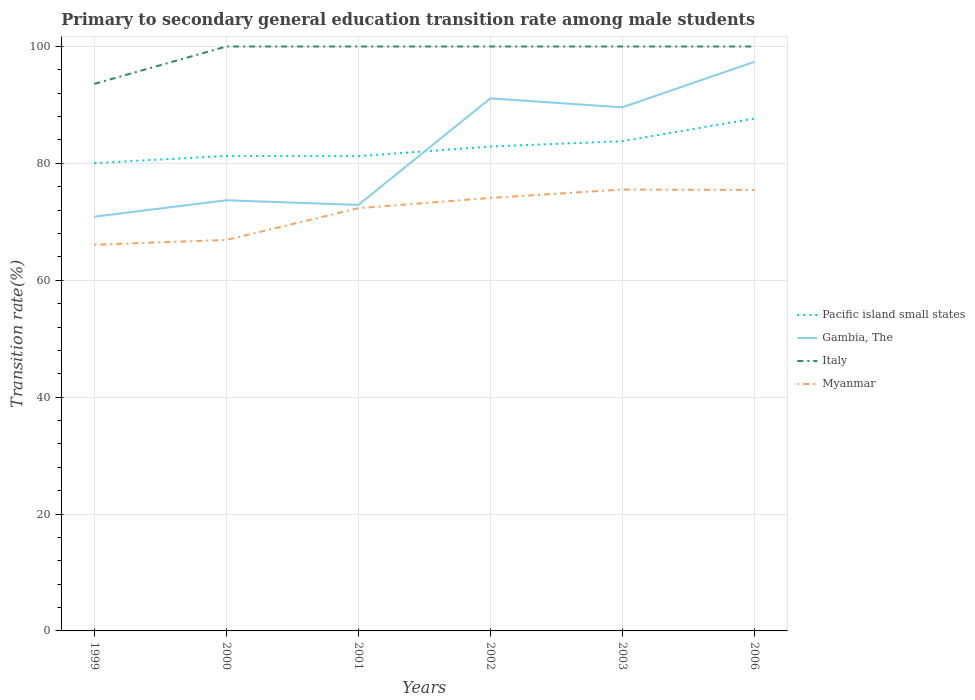Across all years, what is the maximum transition rate in Gambia, The?
Provide a succinct answer. 70.88. In which year was the transition rate in Pacific island small states maximum?
Offer a very short reply. 1999. What is the total transition rate in Italy in the graph?
Offer a very short reply. 0. What is the difference between the highest and the second highest transition rate in Italy?
Make the answer very short. 6.4. What is the difference between the highest and the lowest transition rate in Gambia, The?
Offer a very short reply. 3. Is the transition rate in Myanmar strictly greater than the transition rate in Italy over the years?
Make the answer very short. Yes. How many lines are there?
Provide a succinct answer. 4. Are the values on the major ticks of Y-axis written in scientific E-notation?
Offer a terse response. No. Does the graph contain grids?
Offer a terse response. Yes. Where does the legend appear in the graph?
Your answer should be very brief. Center right. How are the legend labels stacked?
Give a very brief answer. Vertical. What is the title of the graph?
Make the answer very short. Primary to secondary general education transition rate among male students. Does "Zambia" appear as one of the legend labels in the graph?
Your answer should be very brief. No. What is the label or title of the Y-axis?
Offer a terse response. Transition rate(%). What is the Transition rate(%) in Pacific island small states in 1999?
Your answer should be compact. 80.04. What is the Transition rate(%) in Gambia, The in 1999?
Your answer should be compact. 70.88. What is the Transition rate(%) in Italy in 1999?
Provide a succinct answer. 93.6. What is the Transition rate(%) of Myanmar in 1999?
Keep it short and to the point. 66.07. What is the Transition rate(%) in Pacific island small states in 2000?
Offer a very short reply. 81.27. What is the Transition rate(%) in Gambia, The in 2000?
Ensure brevity in your answer.  73.69. What is the Transition rate(%) in Myanmar in 2000?
Make the answer very short. 66.9. What is the Transition rate(%) in Pacific island small states in 2001?
Offer a terse response. 81.23. What is the Transition rate(%) in Gambia, The in 2001?
Give a very brief answer. 72.89. What is the Transition rate(%) in Italy in 2001?
Provide a short and direct response. 100. What is the Transition rate(%) of Myanmar in 2001?
Ensure brevity in your answer.  72.33. What is the Transition rate(%) in Pacific island small states in 2002?
Provide a short and direct response. 82.88. What is the Transition rate(%) in Gambia, The in 2002?
Offer a terse response. 91.12. What is the Transition rate(%) of Myanmar in 2002?
Offer a terse response. 74.09. What is the Transition rate(%) of Pacific island small states in 2003?
Offer a terse response. 83.8. What is the Transition rate(%) in Gambia, The in 2003?
Offer a terse response. 89.59. What is the Transition rate(%) of Myanmar in 2003?
Provide a short and direct response. 75.52. What is the Transition rate(%) in Pacific island small states in 2006?
Your answer should be compact. 87.67. What is the Transition rate(%) of Gambia, The in 2006?
Your answer should be compact. 97.38. What is the Transition rate(%) in Myanmar in 2006?
Your answer should be very brief. 75.45. Across all years, what is the maximum Transition rate(%) of Pacific island small states?
Ensure brevity in your answer.  87.67. Across all years, what is the maximum Transition rate(%) in Gambia, The?
Ensure brevity in your answer.  97.38. Across all years, what is the maximum Transition rate(%) in Italy?
Offer a very short reply. 100. Across all years, what is the maximum Transition rate(%) of Myanmar?
Your answer should be very brief. 75.52. Across all years, what is the minimum Transition rate(%) in Pacific island small states?
Offer a very short reply. 80.04. Across all years, what is the minimum Transition rate(%) in Gambia, The?
Your answer should be very brief. 70.88. Across all years, what is the minimum Transition rate(%) in Italy?
Your response must be concise. 93.6. Across all years, what is the minimum Transition rate(%) in Myanmar?
Your answer should be compact. 66.07. What is the total Transition rate(%) in Pacific island small states in the graph?
Offer a very short reply. 496.89. What is the total Transition rate(%) in Gambia, The in the graph?
Provide a short and direct response. 495.54. What is the total Transition rate(%) in Italy in the graph?
Your response must be concise. 593.6. What is the total Transition rate(%) in Myanmar in the graph?
Offer a very short reply. 430.37. What is the difference between the Transition rate(%) of Pacific island small states in 1999 and that in 2000?
Keep it short and to the point. -1.24. What is the difference between the Transition rate(%) in Gambia, The in 1999 and that in 2000?
Ensure brevity in your answer.  -2.81. What is the difference between the Transition rate(%) of Italy in 1999 and that in 2000?
Your answer should be very brief. -6.4. What is the difference between the Transition rate(%) in Myanmar in 1999 and that in 2000?
Give a very brief answer. -0.83. What is the difference between the Transition rate(%) of Pacific island small states in 1999 and that in 2001?
Offer a very short reply. -1.2. What is the difference between the Transition rate(%) of Gambia, The in 1999 and that in 2001?
Ensure brevity in your answer.  -2.01. What is the difference between the Transition rate(%) in Italy in 1999 and that in 2001?
Make the answer very short. -6.4. What is the difference between the Transition rate(%) of Myanmar in 1999 and that in 2001?
Your answer should be very brief. -6.25. What is the difference between the Transition rate(%) in Pacific island small states in 1999 and that in 2002?
Your answer should be very brief. -2.84. What is the difference between the Transition rate(%) in Gambia, The in 1999 and that in 2002?
Offer a terse response. -20.24. What is the difference between the Transition rate(%) of Italy in 1999 and that in 2002?
Your response must be concise. -6.4. What is the difference between the Transition rate(%) in Myanmar in 1999 and that in 2002?
Keep it short and to the point. -8.02. What is the difference between the Transition rate(%) of Pacific island small states in 1999 and that in 2003?
Keep it short and to the point. -3.76. What is the difference between the Transition rate(%) of Gambia, The in 1999 and that in 2003?
Offer a very short reply. -18.71. What is the difference between the Transition rate(%) of Italy in 1999 and that in 2003?
Give a very brief answer. -6.4. What is the difference between the Transition rate(%) of Myanmar in 1999 and that in 2003?
Your answer should be compact. -9.45. What is the difference between the Transition rate(%) of Pacific island small states in 1999 and that in 2006?
Provide a succinct answer. -7.63. What is the difference between the Transition rate(%) of Gambia, The in 1999 and that in 2006?
Your response must be concise. -26.5. What is the difference between the Transition rate(%) in Italy in 1999 and that in 2006?
Give a very brief answer. -6.4. What is the difference between the Transition rate(%) in Myanmar in 1999 and that in 2006?
Your answer should be very brief. -9.38. What is the difference between the Transition rate(%) in Pacific island small states in 2000 and that in 2001?
Ensure brevity in your answer.  0.04. What is the difference between the Transition rate(%) of Gambia, The in 2000 and that in 2001?
Offer a very short reply. 0.8. What is the difference between the Transition rate(%) of Myanmar in 2000 and that in 2001?
Your response must be concise. -5.43. What is the difference between the Transition rate(%) of Pacific island small states in 2000 and that in 2002?
Ensure brevity in your answer.  -1.61. What is the difference between the Transition rate(%) of Gambia, The in 2000 and that in 2002?
Your answer should be compact. -17.43. What is the difference between the Transition rate(%) of Myanmar in 2000 and that in 2002?
Your answer should be compact. -7.19. What is the difference between the Transition rate(%) in Pacific island small states in 2000 and that in 2003?
Provide a short and direct response. -2.52. What is the difference between the Transition rate(%) in Gambia, The in 2000 and that in 2003?
Provide a short and direct response. -15.9. What is the difference between the Transition rate(%) in Myanmar in 2000 and that in 2003?
Offer a terse response. -8.62. What is the difference between the Transition rate(%) of Pacific island small states in 2000 and that in 2006?
Keep it short and to the point. -6.4. What is the difference between the Transition rate(%) in Gambia, The in 2000 and that in 2006?
Your answer should be very brief. -23.69. What is the difference between the Transition rate(%) in Italy in 2000 and that in 2006?
Ensure brevity in your answer.  0. What is the difference between the Transition rate(%) in Myanmar in 2000 and that in 2006?
Your answer should be compact. -8.55. What is the difference between the Transition rate(%) in Pacific island small states in 2001 and that in 2002?
Your response must be concise. -1.65. What is the difference between the Transition rate(%) in Gambia, The in 2001 and that in 2002?
Offer a very short reply. -18.23. What is the difference between the Transition rate(%) of Myanmar in 2001 and that in 2002?
Give a very brief answer. -1.76. What is the difference between the Transition rate(%) in Pacific island small states in 2001 and that in 2003?
Provide a short and direct response. -2.56. What is the difference between the Transition rate(%) of Gambia, The in 2001 and that in 2003?
Offer a terse response. -16.7. What is the difference between the Transition rate(%) of Myanmar in 2001 and that in 2003?
Ensure brevity in your answer.  -3.19. What is the difference between the Transition rate(%) of Pacific island small states in 2001 and that in 2006?
Your answer should be very brief. -6.44. What is the difference between the Transition rate(%) in Gambia, The in 2001 and that in 2006?
Ensure brevity in your answer.  -24.49. What is the difference between the Transition rate(%) of Myanmar in 2001 and that in 2006?
Provide a succinct answer. -3.12. What is the difference between the Transition rate(%) of Pacific island small states in 2002 and that in 2003?
Ensure brevity in your answer.  -0.92. What is the difference between the Transition rate(%) in Gambia, The in 2002 and that in 2003?
Your response must be concise. 1.53. What is the difference between the Transition rate(%) of Italy in 2002 and that in 2003?
Offer a very short reply. 0. What is the difference between the Transition rate(%) in Myanmar in 2002 and that in 2003?
Your answer should be very brief. -1.43. What is the difference between the Transition rate(%) in Pacific island small states in 2002 and that in 2006?
Ensure brevity in your answer.  -4.79. What is the difference between the Transition rate(%) of Gambia, The in 2002 and that in 2006?
Your answer should be very brief. -6.26. What is the difference between the Transition rate(%) in Italy in 2002 and that in 2006?
Your response must be concise. 0. What is the difference between the Transition rate(%) in Myanmar in 2002 and that in 2006?
Provide a short and direct response. -1.36. What is the difference between the Transition rate(%) in Pacific island small states in 2003 and that in 2006?
Ensure brevity in your answer.  -3.87. What is the difference between the Transition rate(%) in Gambia, The in 2003 and that in 2006?
Make the answer very short. -7.79. What is the difference between the Transition rate(%) in Myanmar in 2003 and that in 2006?
Ensure brevity in your answer.  0.07. What is the difference between the Transition rate(%) of Pacific island small states in 1999 and the Transition rate(%) of Gambia, The in 2000?
Keep it short and to the point. 6.35. What is the difference between the Transition rate(%) of Pacific island small states in 1999 and the Transition rate(%) of Italy in 2000?
Your answer should be very brief. -19.96. What is the difference between the Transition rate(%) of Pacific island small states in 1999 and the Transition rate(%) of Myanmar in 2000?
Give a very brief answer. 13.14. What is the difference between the Transition rate(%) in Gambia, The in 1999 and the Transition rate(%) in Italy in 2000?
Offer a terse response. -29.12. What is the difference between the Transition rate(%) in Gambia, The in 1999 and the Transition rate(%) in Myanmar in 2000?
Your answer should be very brief. 3.98. What is the difference between the Transition rate(%) in Italy in 1999 and the Transition rate(%) in Myanmar in 2000?
Offer a very short reply. 26.7. What is the difference between the Transition rate(%) of Pacific island small states in 1999 and the Transition rate(%) of Gambia, The in 2001?
Your response must be concise. 7.15. What is the difference between the Transition rate(%) in Pacific island small states in 1999 and the Transition rate(%) in Italy in 2001?
Ensure brevity in your answer.  -19.96. What is the difference between the Transition rate(%) of Pacific island small states in 1999 and the Transition rate(%) of Myanmar in 2001?
Your answer should be very brief. 7.71. What is the difference between the Transition rate(%) of Gambia, The in 1999 and the Transition rate(%) of Italy in 2001?
Offer a terse response. -29.12. What is the difference between the Transition rate(%) of Gambia, The in 1999 and the Transition rate(%) of Myanmar in 2001?
Offer a terse response. -1.45. What is the difference between the Transition rate(%) of Italy in 1999 and the Transition rate(%) of Myanmar in 2001?
Give a very brief answer. 21.28. What is the difference between the Transition rate(%) in Pacific island small states in 1999 and the Transition rate(%) in Gambia, The in 2002?
Make the answer very short. -11.08. What is the difference between the Transition rate(%) in Pacific island small states in 1999 and the Transition rate(%) in Italy in 2002?
Make the answer very short. -19.96. What is the difference between the Transition rate(%) in Pacific island small states in 1999 and the Transition rate(%) in Myanmar in 2002?
Your answer should be very brief. 5.95. What is the difference between the Transition rate(%) of Gambia, The in 1999 and the Transition rate(%) of Italy in 2002?
Keep it short and to the point. -29.12. What is the difference between the Transition rate(%) in Gambia, The in 1999 and the Transition rate(%) in Myanmar in 2002?
Provide a succinct answer. -3.21. What is the difference between the Transition rate(%) in Italy in 1999 and the Transition rate(%) in Myanmar in 2002?
Your response must be concise. 19.51. What is the difference between the Transition rate(%) in Pacific island small states in 1999 and the Transition rate(%) in Gambia, The in 2003?
Your response must be concise. -9.55. What is the difference between the Transition rate(%) in Pacific island small states in 1999 and the Transition rate(%) in Italy in 2003?
Your answer should be compact. -19.96. What is the difference between the Transition rate(%) of Pacific island small states in 1999 and the Transition rate(%) of Myanmar in 2003?
Your response must be concise. 4.51. What is the difference between the Transition rate(%) in Gambia, The in 1999 and the Transition rate(%) in Italy in 2003?
Keep it short and to the point. -29.12. What is the difference between the Transition rate(%) in Gambia, The in 1999 and the Transition rate(%) in Myanmar in 2003?
Ensure brevity in your answer.  -4.64. What is the difference between the Transition rate(%) in Italy in 1999 and the Transition rate(%) in Myanmar in 2003?
Offer a terse response. 18.08. What is the difference between the Transition rate(%) in Pacific island small states in 1999 and the Transition rate(%) in Gambia, The in 2006?
Your answer should be very brief. -17.34. What is the difference between the Transition rate(%) of Pacific island small states in 1999 and the Transition rate(%) of Italy in 2006?
Ensure brevity in your answer.  -19.96. What is the difference between the Transition rate(%) of Pacific island small states in 1999 and the Transition rate(%) of Myanmar in 2006?
Your answer should be compact. 4.59. What is the difference between the Transition rate(%) of Gambia, The in 1999 and the Transition rate(%) of Italy in 2006?
Give a very brief answer. -29.12. What is the difference between the Transition rate(%) of Gambia, The in 1999 and the Transition rate(%) of Myanmar in 2006?
Give a very brief answer. -4.57. What is the difference between the Transition rate(%) of Italy in 1999 and the Transition rate(%) of Myanmar in 2006?
Keep it short and to the point. 18.15. What is the difference between the Transition rate(%) in Pacific island small states in 2000 and the Transition rate(%) in Gambia, The in 2001?
Your response must be concise. 8.38. What is the difference between the Transition rate(%) of Pacific island small states in 2000 and the Transition rate(%) of Italy in 2001?
Ensure brevity in your answer.  -18.73. What is the difference between the Transition rate(%) of Pacific island small states in 2000 and the Transition rate(%) of Myanmar in 2001?
Your response must be concise. 8.95. What is the difference between the Transition rate(%) in Gambia, The in 2000 and the Transition rate(%) in Italy in 2001?
Offer a terse response. -26.31. What is the difference between the Transition rate(%) of Gambia, The in 2000 and the Transition rate(%) of Myanmar in 2001?
Provide a succinct answer. 1.36. What is the difference between the Transition rate(%) of Italy in 2000 and the Transition rate(%) of Myanmar in 2001?
Your answer should be very brief. 27.67. What is the difference between the Transition rate(%) of Pacific island small states in 2000 and the Transition rate(%) of Gambia, The in 2002?
Provide a succinct answer. -9.85. What is the difference between the Transition rate(%) in Pacific island small states in 2000 and the Transition rate(%) in Italy in 2002?
Keep it short and to the point. -18.73. What is the difference between the Transition rate(%) in Pacific island small states in 2000 and the Transition rate(%) in Myanmar in 2002?
Provide a succinct answer. 7.18. What is the difference between the Transition rate(%) of Gambia, The in 2000 and the Transition rate(%) of Italy in 2002?
Your response must be concise. -26.31. What is the difference between the Transition rate(%) in Gambia, The in 2000 and the Transition rate(%) in Myanmar in 2002?
Make the answer very short. -0.4. What is the difference between the Transition rate(%) of Italy in 2000 and the Transition rate(%) of Myanmar in 2002?
Provide a succinct answer. 25.91. What is the difference between the Transition rate(%) in Pacific island small states in 2000 and the Transition rate(%) in Gambia, The in 2003?
Ensure brevity in your answer.  -8.32. What is the difference between the Transition rate(%) in Pacific island small states in 2000 and the Transition rate(%) in Italy in 2003?
Your response must be concise. -18.73. What is the difference between the Transition rate(%) of Pacific island small states in 2000 and the Transition rate(%) of Myanmar in 2003?
Keep it short and to the point. 5.75. What is the difference between the Transition rate(%) of Gambia, The in 2000 and the Transition rate(%) of Italy in 2003?
Your answer should be compact. -26.31. What is the difference between the Transition rate(%) in Gambia, The in 2000 and the Transition rate(%) in Myanmar in 2003?
Your answer should be very brief. -1.84. What is the difference between the Transition rate(%) in Italy in 2000 and the Transition rate(%) in Myanmar in 2003?
Provide a succinct answer. 24.48. What is the difference between the Transition rate(%) of Pacific island small states in 2000 and the Transition rate(%) of Gambia, The in 2006?
Your answer should be compact. -16.1. What is the difference between the Transition rate(%) of Pacific island small states in 2000 and the Transition rate(%) of Italy in 2006?
Offer a terse response. -18.73. What is the difference between the Transition rate(%) in Pacific island small states in 2000 and the Transition rate(%) in Myanmar in 2006?
Offer a terse response. 5.82. What is the difference between the Transition rate(%) of Gambia, The in 2000 and the Transition rate(%) of Italy in 2006?
Your answer should be compact. -26.31. What is the difference between the Transition rate(%) of Gambia, The in 2000 and the Transition rate(%) of Myanmar in 2006?
Provide a short and direct response. -1.76. What is the difference between the Transition rate(%) of Italy in 2000 and the Transition rate(%) of Myanmar in 2006?
Offer a terse response. 24.55. What is the difference between the Transition rate(%) of Pacific island small states in 2001 and the Transition rate(%) of Gambia, The in 2002?
Make the answer very short. -9.89. What is the difference between the Transition rate(%) of Pacific island small states in 2001 and the Transition rate(%) of Italy in 2002?
Make the answer very short. -18.77. What is the difference between the Transition rate(%) in Pacific island small states in 2001 and the Transition rate(%) in Myanmar in 2002?
Keep it short and to the point. 7.14. What is the difference between the Transition rate(%) in Gambia, The in 2001 and the Transition rate(%) in Italy in 2002?
Make the answer very short. -27.11. What is the difference between the Transition rate(%) in Gambia, The in 2001 and the Transition rate(%) in Myanmar in 2002?
Offer a very short reply. -1.2. What is the difference between the Transition rate(%) in Italy in 2001 and the Transition rate(%) in Myanmar in 2002?
Your answer should be very brief. 25.91. What is the difference between the Transition rate(%) of Pacific island small states in 2001 and the Transition rate(%) of Gambia, The in 2003?
Your response must be concise. -8.36. What is the difference between the Transition rate(%) of Pacific island small states in 2001 and the Transition rate(%) of Italy in 2003?
Ensure brevity in your answer.  -18.77. What is the difference between the Transition rate(%) in Pacific island small states in 2001 and the Transition rate(%) in Myanmar in 2003?
Offer a terse response. 5.71. What is the difference between the Transition rate(%) in Gambia, The in 2001 and the Transition rate(%) in Italy in 2003?
Ensure brevity in your answer.  -27.11. What is the difference between the Transition rate(%) in Gambia, The in 2001 and the Transition rate(%) in Myanmar in 2003?
Your response must be concise. -2.63. What is the difference between the Transition rate(%) of Italy in 2001 and the Transition rate(%) of Myanmar in 2003?
Give a very brief answer. 24.48. What is the difference between the Transition rate(%) in Pacific island small states in 2001 and the Transition rate(%) in Gambia, The in 2006?
Offer a terse response. -16.14. What is the difference between the Transition rate(%) in Pacific island small states in 2001 and the Transition rate(%) in Italy in 2006?
Keep it short and to the point. -18.77. What is the difference between the Transition rate(%) of Pacific island small states in 2001 and the Transition rate(%) of Myanmar in 2006?
Keep it short and to the point. 5.78. What is the difference between the Transition rate(%) of Gambia, The in 2001 and the Transition rate(%) of Italy in 2006?
Keep it short and to the point. -27.11. What is the difference between the Transition rate(%) in Gambia, The in 2001 and the Transition rate(%) in Myanmar in 2006?
Provide a short and direct response. -2.56. What is the difference between the Transition rate(%) of Italy in 2001 and the Transition rate(%) of Myanmar in 2006?
Provide a short and direct response. 24.55. What is the difference between the Transition rate(%) in Pacific island small states in 2002 and the Transition rate(%) in Gambia, The in 2003?
Provide a short and direct response. -6.71. What is the difference between the Transition rate(%) in Pacific island small states in 2002 and the Transition rate(%) in Italy in 2003?
Give a very brief answer. -17.12. What is the difference between the Transition rate(%) of Pacific island small states in 2002 and the Transition rate(%) of Myanmar in 2003?
Your answer should be compact. 7.36. What is the difference between the Transition rate(%) in Gambia, The in 2002 and the Transition rate(%) in Italy in 2003?
Your response must be concise. -8.88. What is the difference between the Transition rate(%) in Gambia, The in 2002 and the Transition rate(%) in Myanmar in 2003?
Provide a short and direct response. 15.6. What is the difference between the Transition rate(%) of Italy in 2002 and the Transition rate(%) of Myanmar in 2003?
Give a very brief answer. 24.48. What is the difference between the Transition rate(%) in Pacific island small states in 2002 and the Transition rate(%) in Gambia, The in 2006?
Your answer should be very brief. -14.5. What is the difference between the Transition rate(%) in Pacific island small states in 2002 and the Transition rate(%) in Italy in 2006?
Your response must be concise. -17.12. What is the difference between the Transition rate(%) of Pacific island small states in 2002 and the Transition rate(%) of Myanmar in 2006?
Offer a very short reply. 7.43. What is the difference between the Transition rate(%) in Gambia, The in 2002 and the Transition rate(%) in Italy in 2006?
Your answer should be very brief. -8.88. What is the difference between the Transition rate(%) in Gambia, The in 2002 and the Transition rate(%) in Myanmar in 2006?
Offer a terse response. 15.67. What is the difference between the Transition rate(%) of Italy in 2002 and the Transition rate(%) of Myanmar in 2006?
Give a very brief answer. 24.55. What is the difference between the Transition rate(%) in Pacific island small states in 2003 and the Transition rate(%) in Gambia, The in 2006?
Give a very brief answer. -13.58. What is the difference between the Transition rate(%) in Pacific island small states in 2003 and the Transition rate(%) in Italy in 2006?
Ensure brevity in your answer.  -16.2. What is the difference between the Transition rate(%) of Pacific island small states in 2003 and the Transition rate(%) of Myanmar in 2006?
Provide a succinct answer. 8.35. What is the difference between the Transition rate(%) in Gambia, The in 2003 and the Transition rate(%) in Italy in 2006?
Keep it short and to the point. -10.41. What is the difference between the Transition rate(%) in Gambia, The in 2003 and the Transition rate(%) in Myanmar in 2006?
Provide a succinct answer. 14.14. What is the difference between the Transition rate(%) of Italy in 2003 and the Transition rate(%) of Myanmar in 2006?
Provide a succinct answer. 24.55. What is the average Transition rate(%) of Pacific island small states per year?
Keep it short and to the point. 82.81. What is the average Transition rate(%) of Gambia, The per year?
Keep it short and to the point. 82.59. What is the average Transition rate(%) in Italy per year?
Your answer should be very brief. 98.93. What is the average Transition rate(%) in Myanmar per year?
Your response must be concise. 71.73. In the year 1999, what is the difference between the Transition rate(%) of Pacific island small states and Transition rate(%) of Gambia, The?
Ensure brevity in your answer.  9.16. In the year 1999, what is the difference between the Transition rate(%) in Pacific island small states and Transition rate(%) in Italy?
Keep it short and to the point. -13.57. In the year 1999, what is the difference between the Transition rate(%) in Pacific island small states and Transition rate(%) in Myanmar?
Keep it short and to the point. 13.96. In the year 1999, what is the difference between the Transition rate(%) in Gambia, The and Transition rate(%) in Italy?
Make the answer very short. -22.73. In the year 1999, what is the difference between the Transition rate(%) in Gambia, The and Transition rate(%) in Myanmar?
Make the answer very short. 4.8. In the year 1999, what is the difference between the Transition rate(%) in Italy and Transition rate(%) in Myanmar?
Ensure brevity in your answer.  27.53. In the year 2000, what is the difference between the Transition rate(%) in Pacific island small states and Transition rate(%) in Gambia, The?
Your response must be concise. 7.59. In the year 2000, what is the difference between the Transition rate(%) in Pacific island small states and Transition rate(%) in Italy?
Offer a terse response. -18.73. In the year 2000, what is the difference between the Transition rate(%) of Pacific island small states and Transition rate(%) of Myanmar?
Your response must be concise. 14.37. In the year 2000, what is the difference between the Transition rate(%) in Gambia, The and Transition rate(%) in Italy?
Your answer should be very brief. -26.31. In the year 2000, what is the difference between the Transition rate(%) of Gambia, The and Transition rate(%) of Myanmar?
Provide a short and direct response. 6.79. In the year 2000, what is the difference between the Transition rate(%) of Italy and Transition rate(%) of Myanmar?
Keep it short and to the point. 33.1. In the year 2001, what is the difference between the Transition rate(%) of Pacific island small states and Transition rate(%) of Gambia, The?
Provide a short and direct response. 8.34. In the year 2001, what is the difference between the Transition rate(%) of Pacific island small states and Transition rate(%) of Italy?
Your answer should be very brief. -18.77. In the year 2001, what is the difference between the Transition rate(%) of Pacific island small states and Transition rate(%) of Myanmar?
Provide a succinct answer. 8.9. In the year 2001, what is the difference between the Transition rate(%) of Gambia, The and Transition rate(%) of Italy?
Offer a terse response. -27.11. In the year 2001, what is the difference between the Transition rate(%) of Gambia, The and Transition rate(%) of Myanmar?
Offer a terse response. 0.56. In the year 2001, what is the difference between the Transition rate(%) in Italy and Transition rate(%) in Myanmar?
Provide a succinct answer. 27.67. In the year 2002, what is the difference between the Transition rate(%) in Pacific island small states and Transition rate(%) in Gambia, The?
Ensure brevity in your answer.  -8.24. In the year 2002, what is the difference between the Transition rate(%) of Pacific island small states and Transition rate(%) of Italy?
Provide a succinct answer. -17.12. In the year 2002, what is the difference between the Transition rate(%) in Pacific island small states and Transition rate(%) in Myanmar?
Make the answer very short. 8.79. In the year 2002, what is the difference between the Transition rate(%) in Gambia, The and Transition rate(%) in Italy?
Your answer should be very brief. -8.88. In the year 2002, what is the difference between the Transition rate(%) of Gambia, The and Transition rate(%) of Myanmar?
Ensure brevity in your answer.  17.03. In the year 2002, what is the difference between the Transition rate(%) of Italy and Transition rate(%) of Myanmar?
Ensure brevity in your answer.  25.91. In the year 2003, what is the difference between the Transition rate(%) of Pacific island small states and Transition rate(%) of Gambia, The?
Your answer should be compact. -5.79. In the year 2003, what is the difference between the Transition rate(%) in Pacific island small states and Transition rate(%) in Italy?
Offer a terse response. -16.2. In the year 2003, what is the difference between the Transition rate(%) in Pacific island small states and Transition rate(%) in Myanmar?
Offer a terse response. 8.27. In the year 2003, what is the difference between the Transition rate(%) in Gambia, The and Transition rate(%) in Italy?
Your answer should be compact. -10.41. In the year 2003, what is the difference between the Transition rate(%) in Gambia, The and Transition rate(%) in Myanmar?
Offer a very short reply. 14.07. In the year 2003, what is the difference between the Transition rate(%) of Italy and Transition rate(%) of Myanmar?
Your response must be concise. 24.48. In the year 2006, what is the difference between the Transition rate(%) of Pacific island small states and Transition rate(%) of Gambia, The?
Offer a very short reply. -9.71. In the year 2006, what is the difference between the Transition rate(%) in Pacific island small states and Transition rate(%) in Italy?
Ensure brevity in your answer.  -12.33. In the year 2006, what is the difference between the Transition rate(%) in Pacific island small states and Transition rate(%) in Myanmar?
Ensure brevity in your answer.  12.22. In the year 2006, what is the difference between the Transition rate(%) in Gambia, The and Transition rate(%) in Italy?
Offer a terse response. -2.62. In the year 2006, what is the difference between the Transition rate(%) in Gambia, The and Transition rate(%) in Myanmar?
Keep it short and to the point. 21.93. In the year 2006, what is the difference between the Transition rate(%) of Italy and Transition rate(%) of Myanmar?
Provide a succinct answer. 24.55. What is the ratio of the Transition rate(%) in Pacific island small states in 1999 to that in 2000?
Make the answer very short. 0.98. What is the ratio of the Transition rate(%) in Gambia, The in 1999 to that in 2000?
Give a very brief answer. 0.96. What is the ratio of the Transition rate(%) of Italy in 1999 to that in 2000?
Offer a very short reply. 0.94. What is the ratio of the Transition rate(%) in Myanmar in 1999 to that in 2000?
Your response must be concise. 0.99. What is the ratio of the Transition rate(%) of Gambia, The in 1999 to that in 2001?
Your response must be concise. 0.97. What is the ratio of the Transition rate(%) of Italy in 1999 to that in 2001?
Your response must be concise. 0.94. What is the ratio of the Transition rate(%) in Myanmar in 1999 to that in 2001?
Ensure brevity in your answer.  0.91. What is the ratio of the Transition rate(%) of Pacific island small states in 1999 to that in 2002?
Your response must be concise. 0.97. What is the ratio of the Transition rate(%) in Gambia, The in 1999 to that in 2002?
Your answer should be very brief. 0.78. What is the ratio of the Transition rate(%) of Italy in 1999 to that in 2002?
Make the answer very short. 0.94. What is the ratio of the Transition rate(%) of Myanmar in 1999 to that in 2002?
Offer a very short reply. 0.89. What is the ratio of the Transition rate(%) of Pacific island small states in 1999 to that in 2003?
Your answer should be very brief. 0.96. What is the ratio of the Transition rate(%) in Gambia, The in 1999 to that in 2003?
Your answer should be compact. 0.79. What is the ratio of the Transition rate(%) in Italy in 1999 to that in 2003?
Give a very brief answer. 0.94. What is the ratio of the Transition rate(%) of Myanmar in 1999 to that in 2003?
Your response must be concise. 0.87. What is the ratio of the Transition rate(%) in Pacific island small states in 1999 to that in 2006?
Your answer should be very brief. 0.91. What is the ratio of the Transition rate(%) of Gambia, The in 1999 to that in 2006?
Offer a terse response. 0.73. What is the ratio of the Transition rate(%) of Italy in 1999 to that in 2006?
Your answer should be compact. 0.94. What is the ratio of the Transition rate(%) of Myanmar in 1999 to that in 2006?
Provide a succinct answer. 0.88. What is the ratio of the Transition rate(%) in Gambia, The in 2000 to that in 2001?
Your answer should be compact. 1.01. What is the ratio of the Transition rate(%) in Myanmar in 2000 to that in 2001?
Provide a succinct answer. 0.93. What is the ratio of the Transition rate(%) of Pacific island small states in 2000 to that in 2002?
Your response must be concise. 0.98. What is the ratio of the Transition rate(%) in Gambia, The in 2000 to that in 2002?
Your answer should be very brief. 0.81. What is the ratio of the Transition rate(%) in Myanmar in 2000 to that in 2002?
Keep it short and to the point. 0.9. What is the ratio of the Transition rate(%) in Pacific island small states in 2000 to that in 2003?
Give a very brief answer. 0.97. What is the ratio of the Transition rate(%) of Gambia, The in 2000 to that in 2003?
Ensure brevity in your answer.  0.82. What is the ratio of the Transition rate(%) in Italy in 2000 to that in 2003?
Your response must be concise. 1. What is the ratio of the Transition rate(%) of Myanmar in 2000 to that in 2003?
Keep it short and to the point. 0.89. What is the ratio of the Transition rate(%) in Pacific island small states in 2000 to that in 2006?
Provide a short and direct response. 0.93. What is the ratio of the Transition rate(%) of Gambia, The in 2000 to that in 2006?
Offer a terse response. 0.76. What is the ratio of the Transition rate(%) in Italy in 2000 to that in 2006?
Keep it short and to the point. 1. What is the ratio of the Transition rate(%) in Myanmar in 2000 to that in 2006?
Keep it short and to the point. 0.89. What is the ratio of the Transition rate(%) of Pacific island small states in 2001 to that in 2002?
Your answer should be compact. 0.98. What is the ratio of the Transition rate(%) of Gambia, The in 2001 to that in 2002?
Provide a short and direct response. 0.8. What is the ratio of the Transition rate(%) in Myanmar in 2001 to that in 2002?
Provide a succinct answer. 0.98. What is the ratio of the Transition rate(%) in Pacific island small states in 2001 to that in 2003?
Provide a succinct answer. 0.97. What is the ratio of the Transition rate(%) of Gambia, The in 2001 to that in 2003?
Ensure brevity in your answer.  0.81. What is the ratio of the Transition rate(%) in Italy in 2001 to that in 2003?
Keep it short and to the point. 1. What is the ratio of the Transition rate(%) of Myanmar in 2001 to that in 2003?
Offer a very short reply. 0.96. What is the ratio of the Transition rate(%) in Pacific island small states in 2001 to that in 2006?
Give a very brief answer. 0.93. What is the ratio of the Transition rate(%) in Gambia, The in 2001 to that in 2006?
Offer a terse response. 0.75. What is the ratio of the Transition rate(%) in Myanmar in 2001 to that in 2006?
Offer a very short reply. 0.96. What is the ratio of the Transition rate(%) of Gambia, The in 2002 to that in 2003?
Provide a short and direct response. 1.02. What is the ratio of the Transition rate(%) of Myanmar in 2002 to that in 2003?
Offer a very short reply. 0.98. What is the ratio of the Transition rate(%) in Pacific island small states in 2002 to that in 2006?
Your answer should be very brief. 0.95. What is the ratio of the Transition rate(%) in Gambia, The in 2002 to that in 2006?
Offer a very short reply. 0.94. What is the ratio of the Transition rate(%) in Italy in 2002 to that in 2006?
Keep it short and to the point. 1. What is the ratio of the Transition rate(%) in Myanmar in 2002 to that in 2006?
Provide a short and direct response. 0.98. What is the ratio of the Transition rate(%) of Pacific island small states in 2003 to that in 2006?
Ensure brevity in your answer.  0.96. What is the ratio of the Transition rate(%) in Gambia, The in 2003 to that in 2006?
Your answer should be very brief. 0.92. What is the ratio of the Transition rate(%) of Italy in 2003 to that in 2006?
Ensure brevity in your answer.  1. What is the ratio of the Transition rate(%) in Myanmar in 2003 to that in 2006?
Offer a very short reply. 1. What is the difference between the highest and the second highest Transition rate(%) in Pacific island small states?
Offer a terse response. 3.87. What is the difference between the highest and the second highest Transition rate(%) of Gambia, The?
Provide a short and direct response. 6.26. What is the difference between the highest and the second highest Transition rate(%) of Myanmar?
Keep it short and to the point. 0.07. What is the difference between the highest and the lowest Transition rate(%) in Pacific island small states?
Provide a succinct answer. 7.63. What is the difference between the highest and the lowest Transition rate(%) of Gambia, The?
Keep it short and to the point. 26.5. What is the difference between the highest and the lowest Transition rate(%) in Italy?
Give a very brief answer. 6.4. What is the difference between the highest and the lowest Transition rate(%) in Myanmar?
Offer a very short reply. 9.45. 